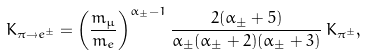Convert formula to latex. <formula><loc_0><loc_0><loc_500><loc_500>K _ { \pi \rightarrow e ^ { \pm } } = \left ( \frac { m _ { \mu } } { m _ { e } } \right ) ^ { \alpha _ { \pm } - 1 } \frac { 2 ( \alpha _ { \pm } + 5 ) } { \alpha _ { \pm } ( \alpha _ { \pm } + 2 ) ( \alpha _ { \pm } + 3 ) } \, K _ { \pi ^ { \pm } } ,</formula> 